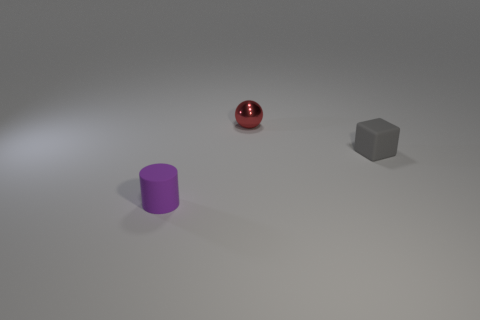Are there any big red metallic objects?
Provide a succinct answer. No. There is a purple matte cylinder; does it have the same size as the object behind the small block?
Your answer should be compact. Yes. There is a tiny thing to the right of the shiny ball; is there a gray thing on the left side of it?
Provide a short and direct response. No. The thing that is in front of the red object and to the left of the gray matte block is made of what material?
Offer a very short reply. Rubber. The rubber thing in front of the rubber thing behind the tiny rubber object that is to the left of the tiny red metallic object is what color?
Provide a succinct answer. Purple. The metallic ball that is the same size as the gray thing is what color?
Provide a short and direct response. Red. There is a tiny ball; does it have the same color as the tiny rubber object to the right of the purple cylinder?
Provide a succinct answer. No. What is the material of the thing that is behind the matte thing that is to the right of the small red metallic sphere?
Your answer should be compact. Metal. What number of rubber objects are both in front of the tiny gray thing and behind the rubber cylinder?
Keep it short and to the point. 0. What number of other things are the same size as the block?
Your answer should be very brief. 2. 